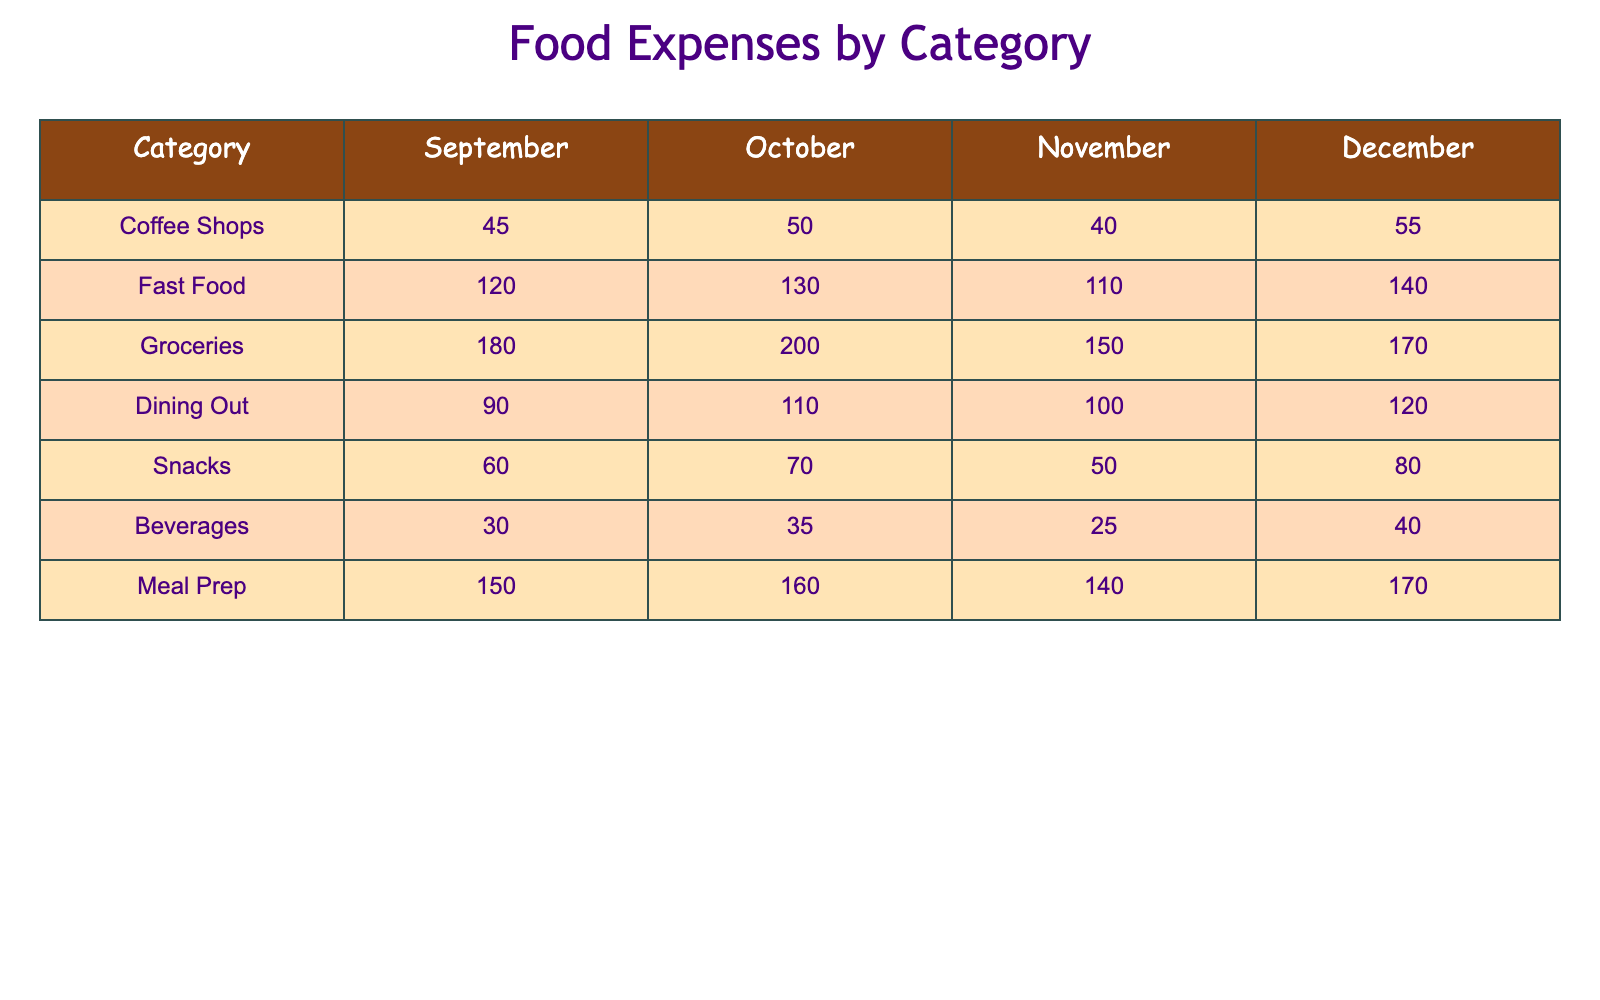What was the total expense for Fast Food over the semester? To find the total expense for Fast Food, we add the values for each month: 120 (September) + 130 (October) + 110 (November) + 140 (December) = 500.
Answer: 500 In which month did Dining Out expenses peak? By examining the values, the highest expense for Dining Out is 120 in December.
Answer: December What is the average expense for Groceries over the semester? We first sum the monthly expenses: 180 + 200 + 150 + 170 = 700. Then, we divide by 4 (the number of months): 700 / 4 = 175.
Answer: 175 Did the expense for Snacks increase every month? The expenses for Snacks are: 60 (September), 70 (October), 50 (November), and 80 (December). The expense decreased in November, so it did not increase every month.
Answer: No Which category had the highest expense in October? In October, the expenses for each category are: Coffee Shops (50), Fast Food (130), Groceries (200), Dining Out (110), Snacks (70), Beverages (35), Meal Prep (160). The highest is Groceries at 200.
Answer: Groceries What is the difference in expenses between Meal Prep in December and Coffee Shops in September? Meal Prep in December is 170, and Coffee Shops in September is 45. The difference is 170 - 45 = 125.
Answer: 125 How much did Beverages cost in total over the semester? The expenses for Beverages are: 30 (September) + 35 (October) + 25 (November) + 40 (December) = 130.
Answer: 130 What percentage of the total food expenses does Fast Food represent in November? In November, Fast Food is 110. The total monthly expenses for all categories in November are: 40 (Coffee Shops) + 110 (Fast Food) + 150 (Groceries) + 100 (Dining Out) + 50 (Snacks) + 25 (Beverages) + 140 (Meal Prep) = 715. The percentage is (110 / 715) * 100 ≈ 15.4%.
Answer: 15.4% 